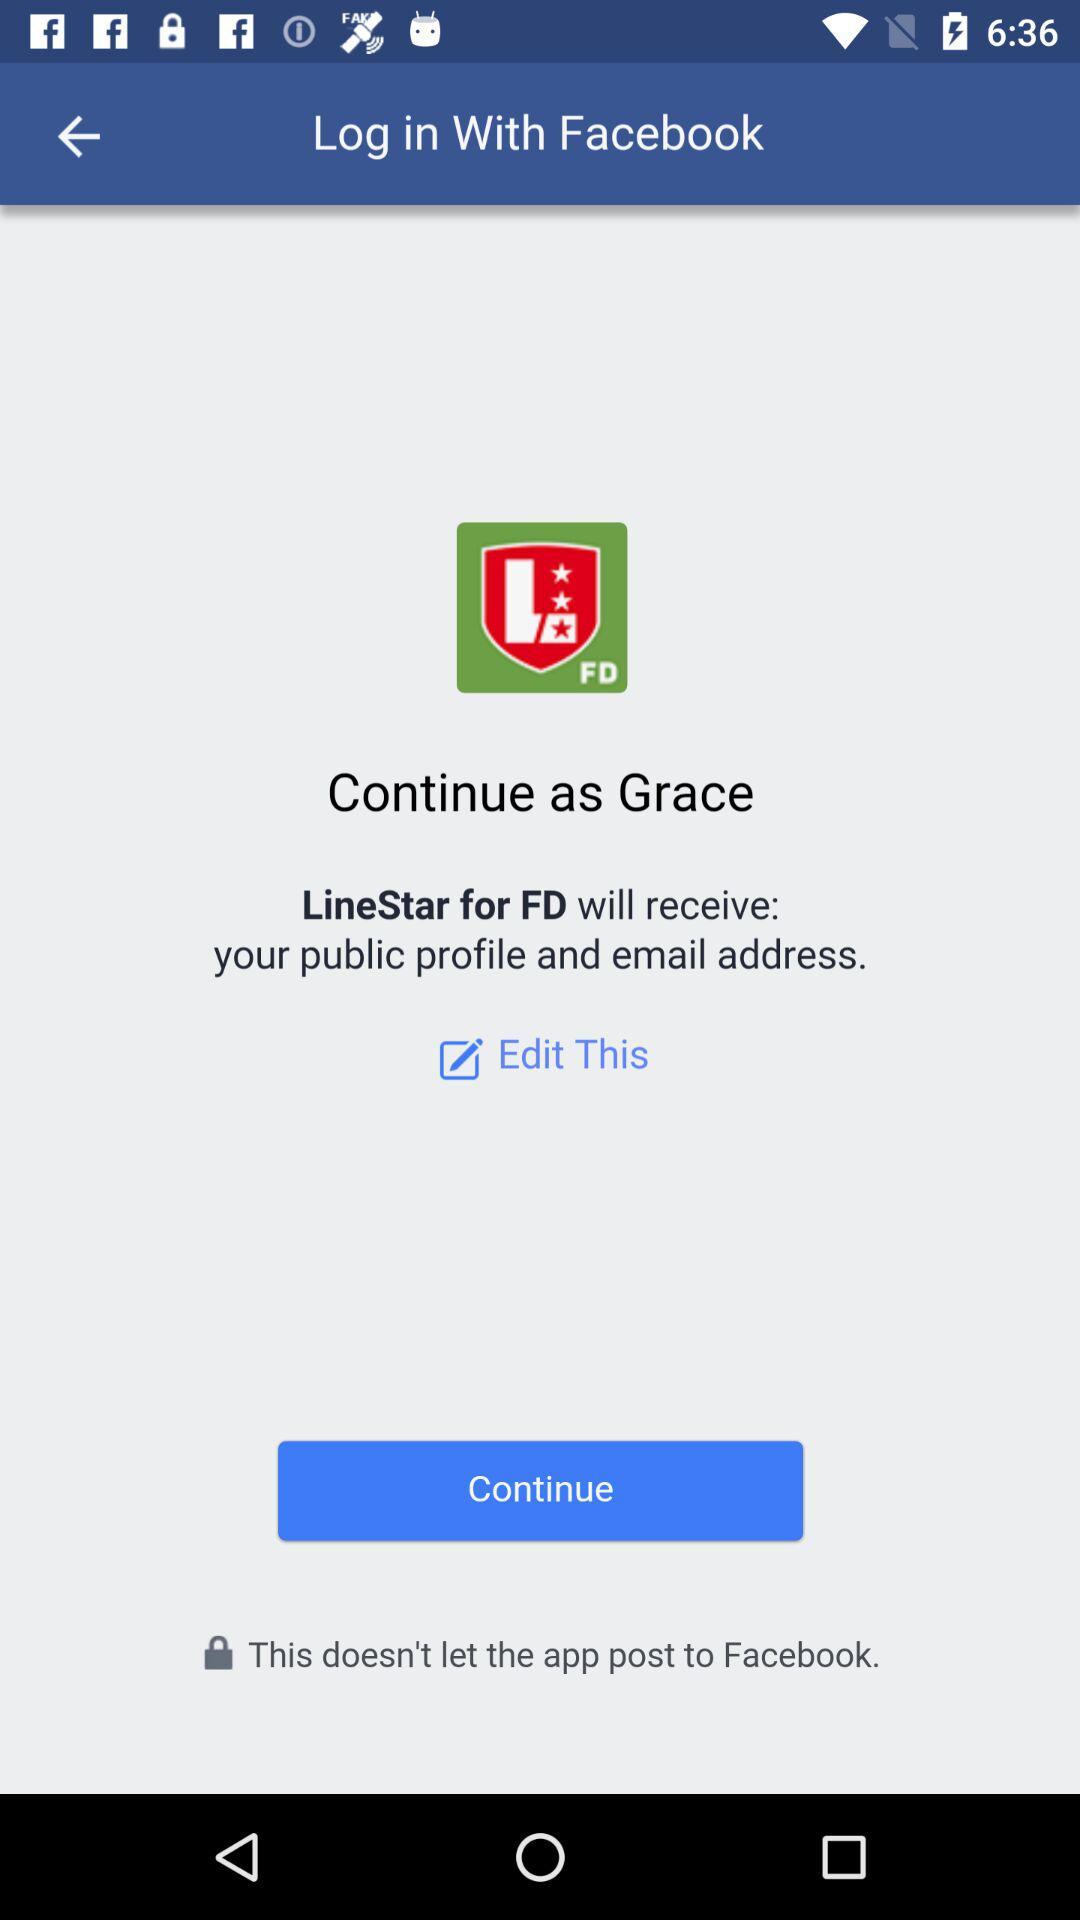Through what account login can be done? Login can be done through "Facebook". 